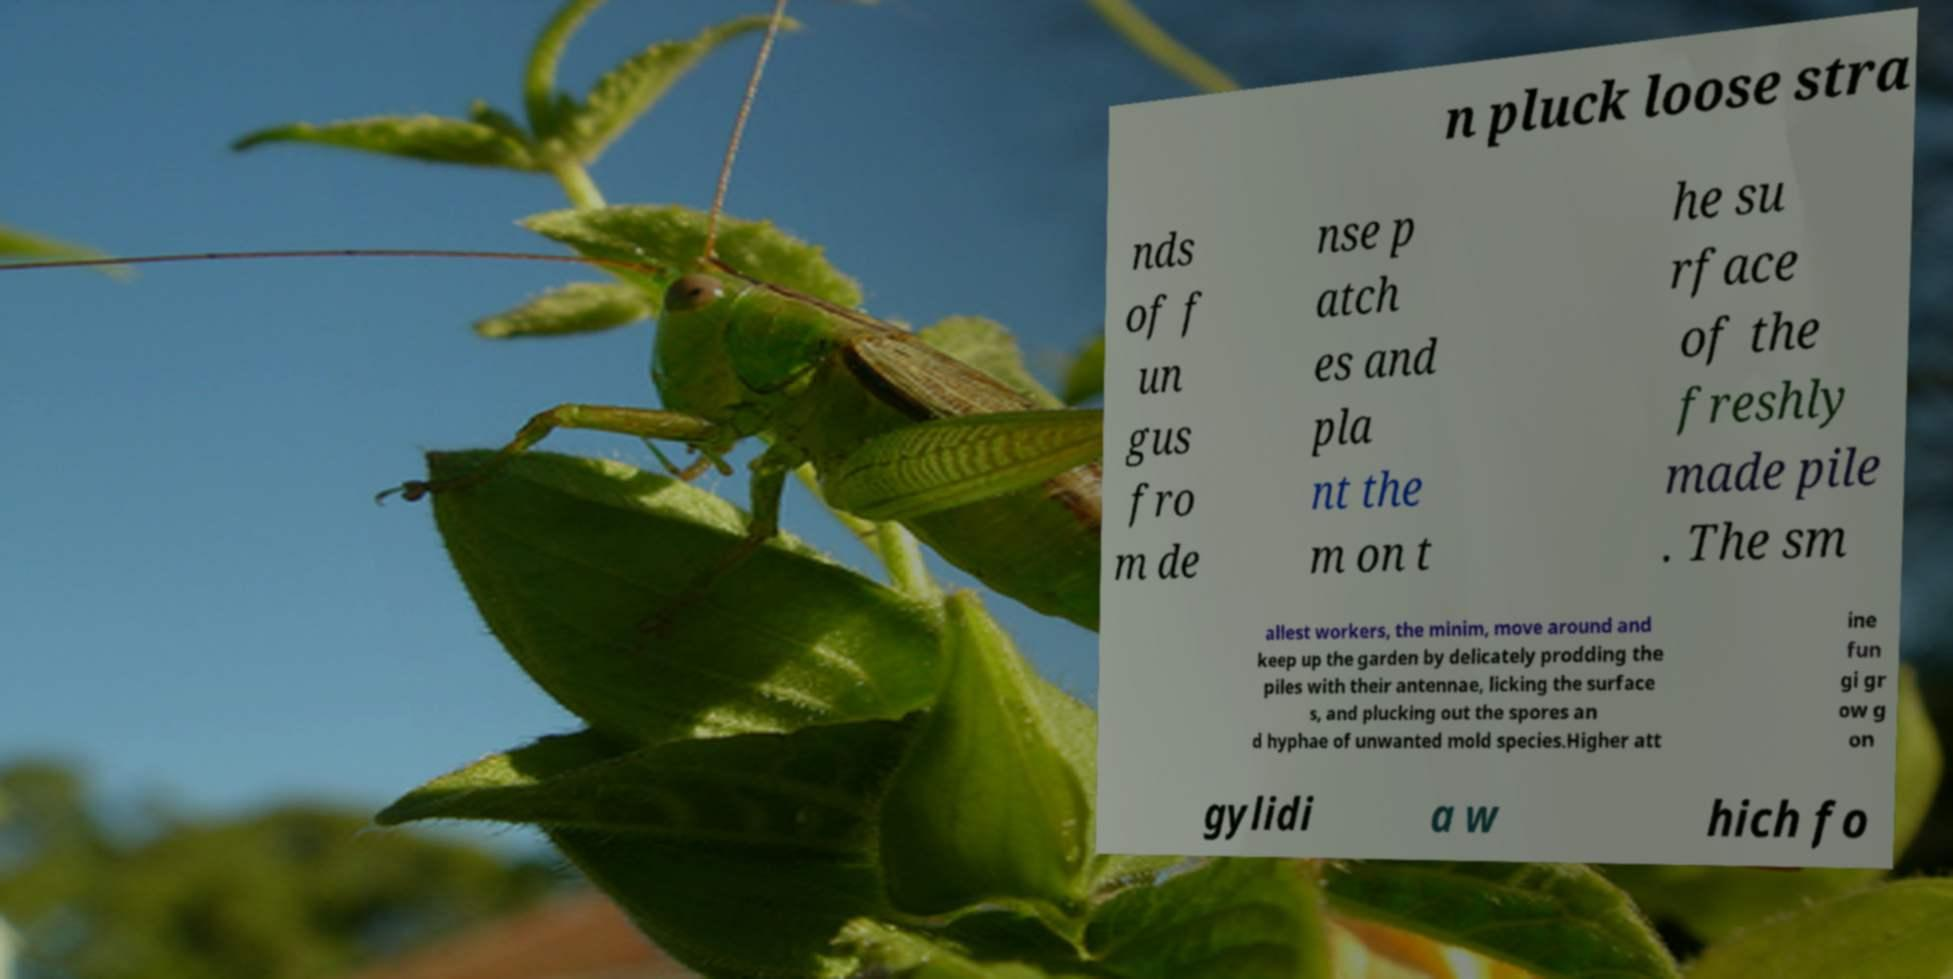I need the written content from this picture converted into text. Can you do that? n pluck loose stra nds of f un gus fro m de nse p atch es and pla nt the m on t he su rface of the freshly made pile . The sm allest workers, the minim, move around and keep up the garden by delicately prodding the piles with their antennae, licking the surface s, and plucking out the spores an d hyphae of unwanted mold species.Higher att ine fun gi gr ow g on gylidi a w hich fo 